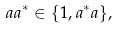<formula> <loc_0><loc_0><loc_500><loc_500>a a ^ { * } \in \{ 1 , a ^ { * } a \} ,</formula> 